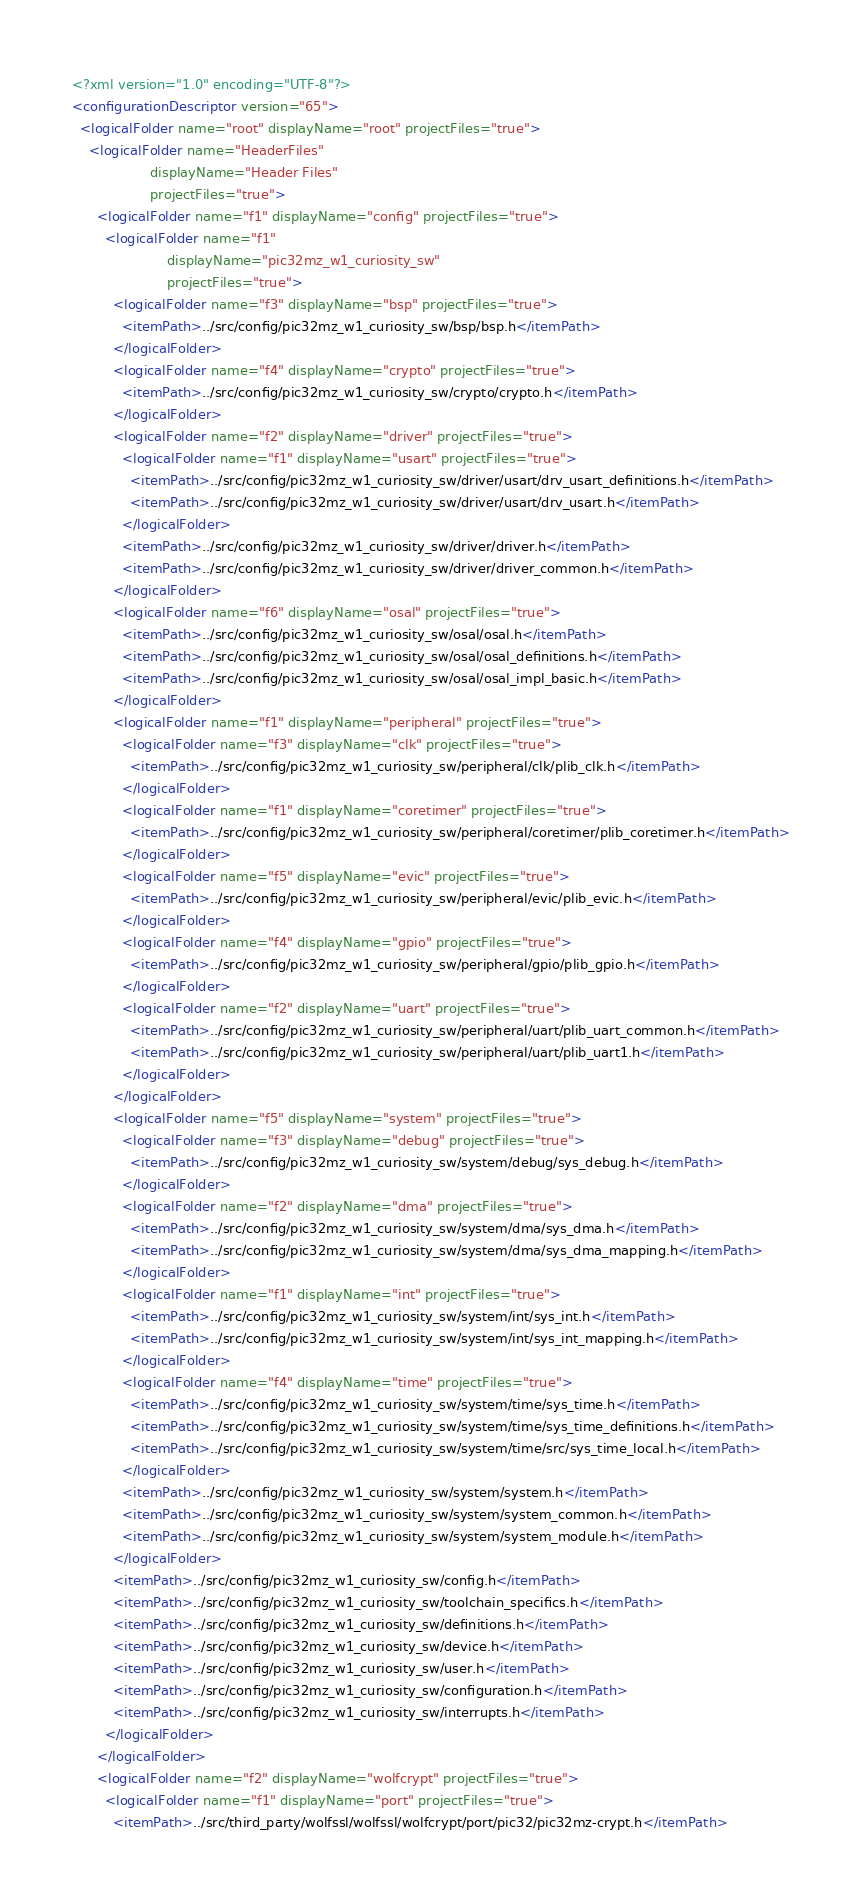<code> <loc_0><loc_0><loc_500><loc_500><_XML_><?xml version="1.0" encoding="UTF-8"?>
<configurationDescriptor version="65">
  <logicalFolder name="root" displayName="root" projectFiles="true">
    <logicalFolder name="HeaderFiles"
                   displayName="Header Files"
                   projectFiles="true">
      <logicalFolder name="f1" displayName="config" projectFiles="true">
        <logicalFolder name="f1"
                       displayName="pic32mz_w1_curiosity_sw"
                       projectFiles="true">
          <logicalFolder name="f3" displayName="bsp" projectFiles="true">
            <itemPath>../src/config/pic32mz_w1_curiosity_sw/bsp/bsp.h</itemPath>
          </logicalFolder>
          <logicalFolder name="f4" displayName="crypto" projectFiles="true">
            <itemPath>../src/config/pic32mz_w1_curiosity_sw/crypto/crypto.h</itemPath>
          </logicalFolder>
          <logicalFolder name="f2" displayName="driver" projectFiles="true">
            <logicalFolder name="f1" displayName="usart" projectFiles="true">
              <itemPath>../src/config/pic32mz_w1_curiosity_sw/driver/usart/drv_usart_definitions.h</itemPath>
              <itemPath>../src/config/pic32mz_w1_curiosity_sw/driver/usart/drv_usart.h</itemPath>
            </logicalFolder>
            <itemPath>../src/config/pic32mz_w1_curiosity_sw/driver/driver.h</itemPath>
            <itemPath>../src/config/pic32mz_w1_curiosity_sw/driver/driver_common.h</itemPath>
          </logicalFolder>
          <logicalFolder name="f6" displayName="osal" projectFiles="true">
            <itemPath>../src/config/pic32mz_w1_curiosity_sw/osal/osal.h</itemPath>
            <itemPath>../src/config/pic32mz_w1_curiosity_sw/osal/osal_definitions.h</itemPath>
            <itemPath>../src/config/pic32mz_w1_curiosity_sw/osal/osal_impl_basic.h</itemPath>
          </logicalFolder>
          <logicalFolder name="f1" displayName="peripheral" projectFiles="true">
            <logicalFolder name="f3" displayName="clk" projectFiles="true">
              <itemPath>../src/config/pic32mz_w1_curiosity_sw/peripheral/clk/plib_clk.h</itemPath>
            </logicalFolder>
            <logicalFolder name="f1" displayName="coretimer" projectFiles="true">
              <itemPath>../src/config/pic32mz_w1_curiosity_sw/peripheral/coretimer/plib_coretimer.h</itemPath>
            </logicalFolder>
            <logicalFolder name="f5" displayName="evic" projectFiles="true">
              <itemPath>../src/config/pic32mz_w1_curiosity_sw/peripheral/evic/plib_evic.h</itemPath>
            </logicalFolder>
            <logicalFolder name="f4" displayName="gpio" projectFiles="true">
              <itemPath>../src/config/pic32mz_w1_curiosity_sw/peripheral/gpio/plib_gpio.h</itemPath>
            </logicalFolder>
            <logicalFolder name="f2" displayName="uart" projectFiles="true">
              <itemPath>../src/config/pic32mz_w1_curiosity_sw/peripheral/uart/plib_uart_common.h</itemPath>
              <itemPath>../src/config/pic32mz_w1_curiosity_sw/peripheral/uart/plib_uart1.h</itemPath>
            </logicalFolder>
          </logicalFolder>
          <logicalFolder name="f5" displayName="system" projectFiles="true">
            <logicalFolder name="f3" displayName="debug" projectFiles="true">
              <itemPath>../src/config/pic32mz_w1_curiosity_sw/system/debug/sys_debug.h</itemPath>
            </logicalFolder>
            <logicalFolder name="f2" displayName="dma" projectFiles="true">
              <itemPath>../src/config/pic32mz_w1_curiosity_sw/system/dma/sys_dma.h</itemPath>
              <itemPath>../src/config/pic32mz_w1_curiosity_sw/system/dma/sys_dma_mapping.h</itemPath>
            </logicalFolder>
            <logicalFolder name="f1" displayName="int" projectFiles="true">
              <itemPath>../src/config/pic32mz_w1_curiosity_sw/system/int/sys_int.h</itemPath>
              <itemPath>../src/config/pic32mz_w1_curiosity_sw/system/int/sys_int_mapping.h</itemPath>
            </logicalFolder>
            <logicalFolder name="f4" displayName="time" projectFiles="true">
              <itemPath>../src/config/pic32mz_w1_curiosity_sw/system/time/sys_time.h</itemPath>
              <itemPath>../src/config/pic32mz_w1_curiosity_sw/system/time/sys_time_definitions.h</itemPath>
              <itemPath>../src/config/pic32mz_w1_curiosity_sw/system/time/src/sys_time_local.h</itemPath>
            </logicalFolder>
            <itemPath>../src/config/pic32mz_w1_curiosity_sw/system/system.h</itemPath>
            <itemPath>../src/config/pic32mz_w1_curiosity_sw/system/system_common.h</itemPath>
            <itemPath>../src/config/pic32mz_w1_curiosity_sw/system/system_module.h</itemPath>
          </logicalFolder>
          <itemPath>../src/config/pic32mz_w1_curiosity_sw/config.h</itemPath>
          <itemPath>../src/config/pic32mz_w1_curiosity_sw/toolchain_specifics.h</itemPath>
          <itemPath>../src/config/pic32mz_w1_curiosity_sw/definitions.h</itemPath>
          <itemPath>../src/config/pic32mz_w1_curiosity_sw/device.h</itemPath>
          <itemPath>../src/config/pic32mz_w1_curiosity_sw/user.h</itemPath>
          <itemPath>../src/config/pic32mz_w1_curiosity_sw/configuration.h</itemPath>
          <itemPath>../src/config/pic32mz_w1_curiosity_sw/interrupts.h</itemPath>
        </logicalFolder>
      </logicalFolder>
      <logicalFolder name="f2" displayName="wolfcrypt" projectFiles="true">
        <logicalFolder name="f1" displayName="port" projectFiles="true">
          <itemPath>../src/third_party/wolfssl/wolfssl/wolfcrypt/port/pic32/pic32mz-crypt.h</itemPath></code> 